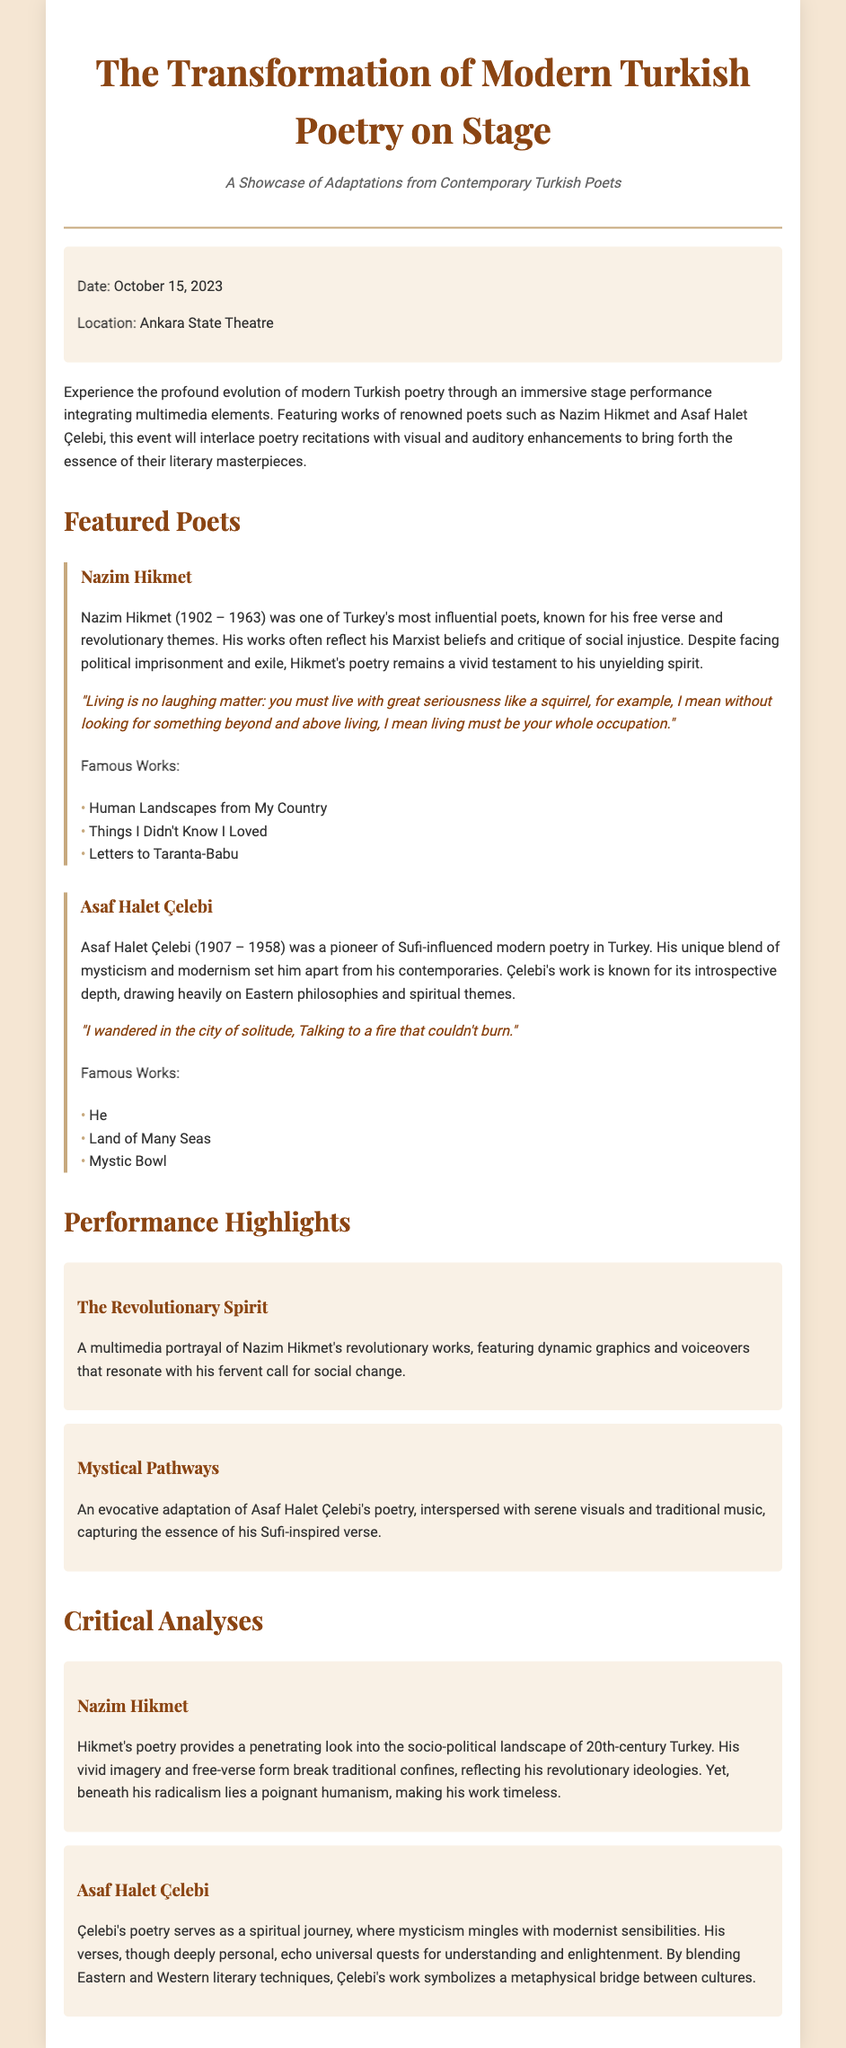What is the date of the event? The date is explicitly stated in the document.
Answer: October 15, 2023 Where will the event take place? The location is specified in the event details section.
Answer: Ankara State Theatre Who is a featured poet known for his revolutionary themes? The document mentions poets and highlights their themes.
Answer: Nazim Hikmet What multimedia element is featured in Nazim Hikmet's performance? The performance highlights describe specific elements used in the showcases.
Answer: Dynamic graphics Which poet is associated with Sufi-influenced modern poetry? The document identifies the literary style associated with each poet.
Answer: Asaf Halet Çelebi What type of analyses are provided for the poets? The document categorizes the content into sections, indicating the nature of the content.
Answer: Critical analyses How does Nazim Hikmet's poetry reflect his ideologies? The critical analysis describes the overarching themes and ideologies of his works.
Answer: Revolutionary ideologies What is the term used to describe Asaf Halet Çelebi's poetry? The document outlines the characteristics of his work in the analysis section.
Answer: Spiritual journey 